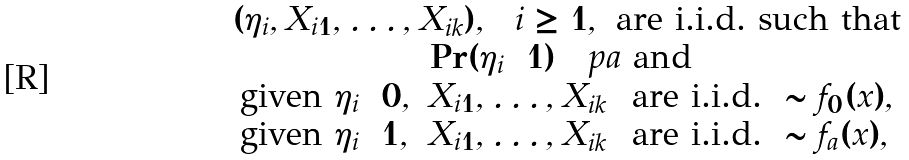Convert formula to latex. <formula><loc_0><loc_0><loc_500><loc_500>\begin{array} { c } ( \eta _ { i } , X _ { i 1 } , \dots , X _ { i k } ) , \ \ i \geq 1 , \text { are    i.i.d.\ such that} \\ \Pr ( \eta _ { i } = 1 ) = \ p a \text { and } \\ \begin{array} { l l } \text {given $\eta_{i}=0$} , & X _ { i 1 } , \dots , X _ { i k } \ \text { are i.i.d.} \ \sim f _ { 0 } ( x ) , \\ \text {given $\eta_{i}=1$} , & X _ { i 1 } , \dots , X _ { i k } \ \text { are i.i.d.} \ \sim f _ { a } ( x ) , \end{array} \end{array}</formula> 